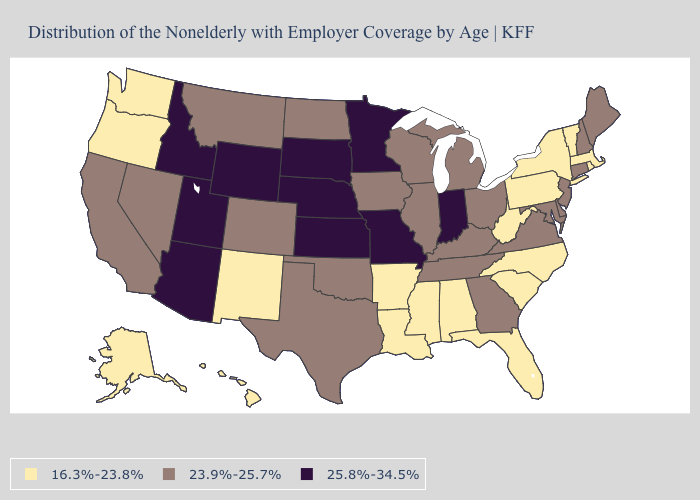Among the states that border California , which have the lowest value?
Answer briefly. Oregon. What is the highest value in the South ?
Answer briefly. 23.9%-25.7%. What is the value of Florida?
Keep it brief. 16.3%-23.8%. What is the value of Pennsylvania?
Quick response, please. 16.3%-23.8%. Among the states that border Idaho , which have the highest value?
Write a very short answer. Utah, Wyoming. Among the states that border Colorado , does Oklahoma have the highest value?
Keep it brief. No. What is the value of Ohio?
Quick response, please. 23.9%-25.7%. What is the value of Maine?
Short answer required. 23.9%-25.7%. Name the states that have a value in the range 23.9%-25.7%?
Give a very brief answer. California, Colorado, Connecticut, Delaware, Georgia, Illinois, Iowa, Kentucky, Maine, Maryland, Michigan, Montana, Nevada, New Hampshire, New Jersey, North Dakota, Ohio, Oklahoma, Tennessee, Texas, Virginia, Wisconsin. What is the lowest value in states that border Tennessee?
Write a very short answer. 16.3%-23.8%. What is the value of Oklahoma?
Be succinct. 23.9%-25.7%. Among the states that border California , which have the highest value?
Answer briefly. Arizona. What is the value of Utah?
Quick response, please. 25.8%-34.5%. Does Florida have the lowest value in the USA?
Answer briefly. Yes. Does North Dakota have the highest value in the MidWest?
Be succinct. No. 